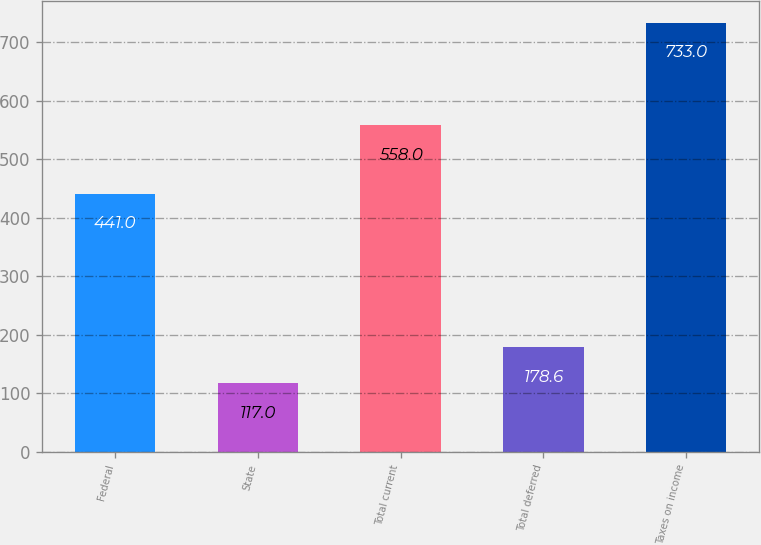Convert chart. <chart><loc_0><loc_0><loc_500><loc_500><bar_chart><fcel>Federal<fcel>State<fcel>Total current<fcel>Total deferred<fcel>Taxes on income<nl><fcel>441<fcel>117<fcel>558<fcel>178.6<fcel>733<nl></chart> 